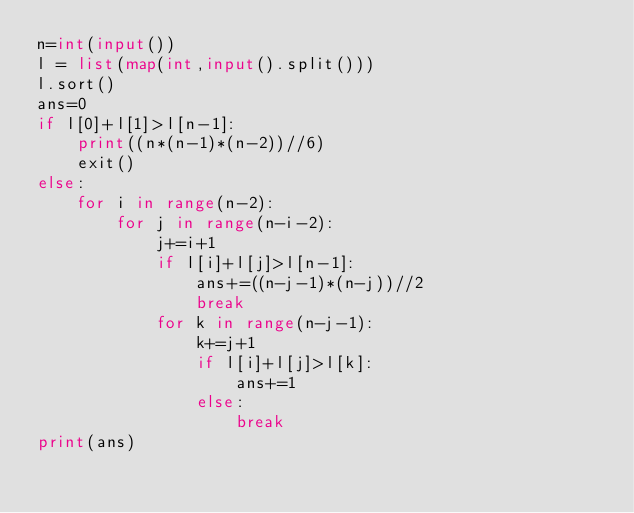Convert code to text. <code><loc_0><loc_0><loc_500><loc_500><_Python_>n=int(input())
l = list(map(int,input().split()))	
l.sort()
ans=0
if l[0]+l[1]>l[n-1]:
    print((n*(n-1)*(n-2))//6)
    exit()
else:
    for i in range(n-2):
        for j in range(n-i-2):
            j+=i+1
            if l[i]+l[j]>l[n-1]:
                ans+=((n-j-1)*(n-j))//2
                break
            for k in range(n-j-1):
                k+=j+1
                if l[i]+l[j]>l[k]:
                    ans+=1
                else:
                    break
print(ans)
</code> 